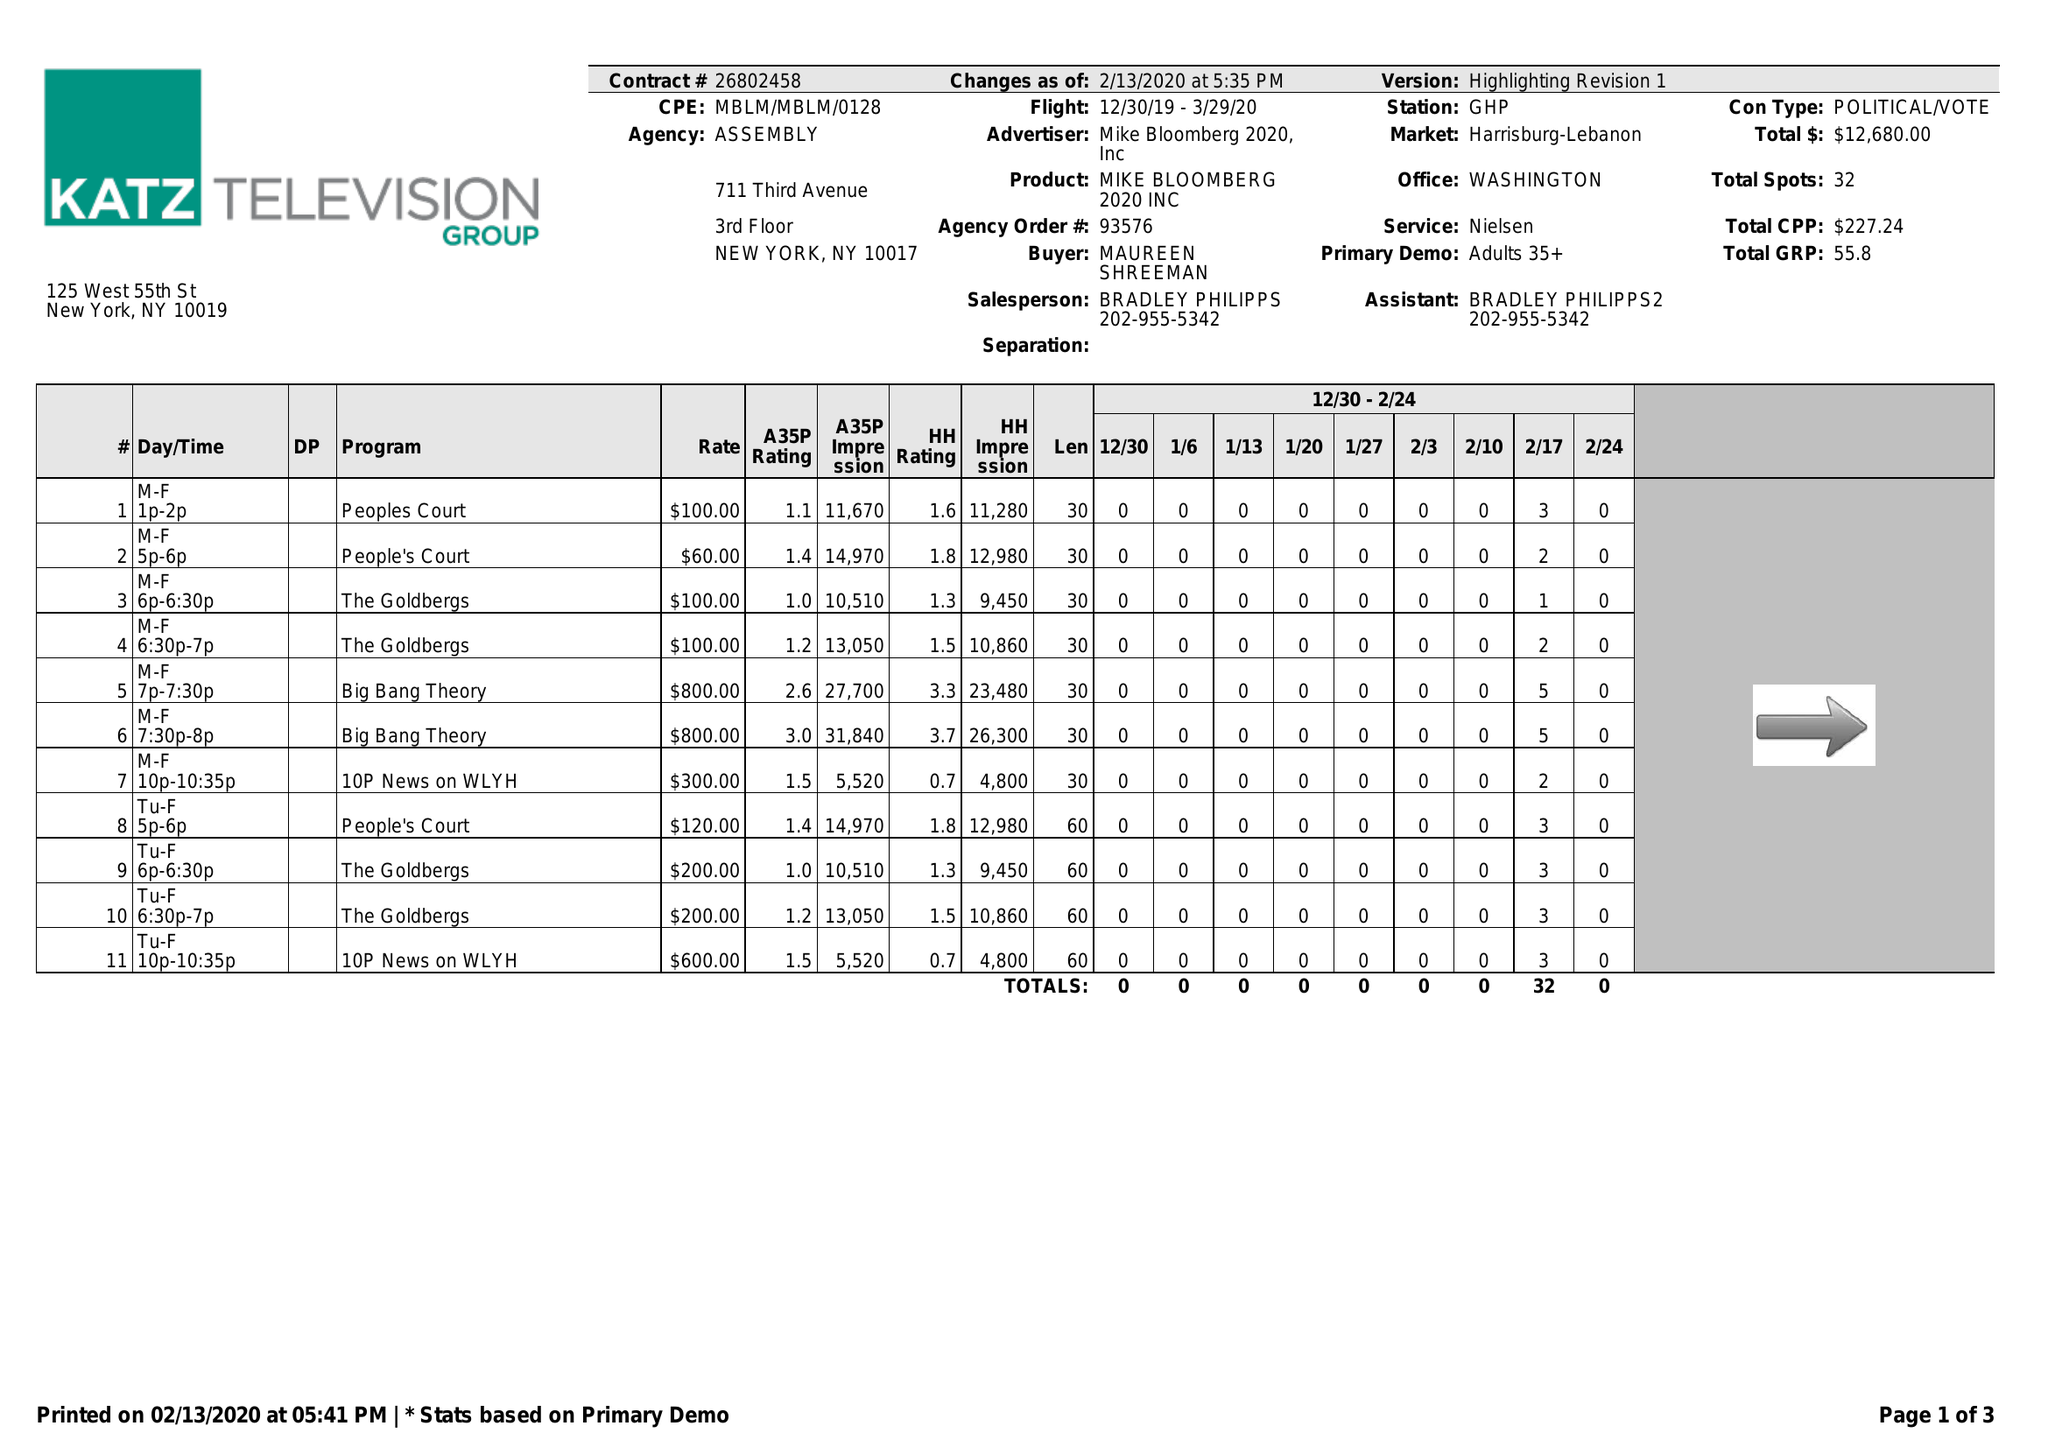What is the value for the gross_amount?
Answer the question using a single word or phrase. 12680.00 